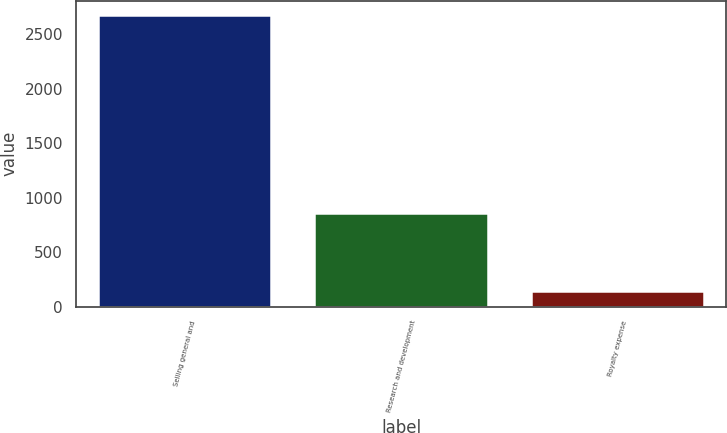Convert chart to OTSL. <chart><loc_0><loc_0><loc_500><loc_500><bar_chart><fcel>Selling general and<fcel>Research and development<fcel>Royalty expense<nl><fcel>2674<fcel>861<fcel>140<nl></chart> 